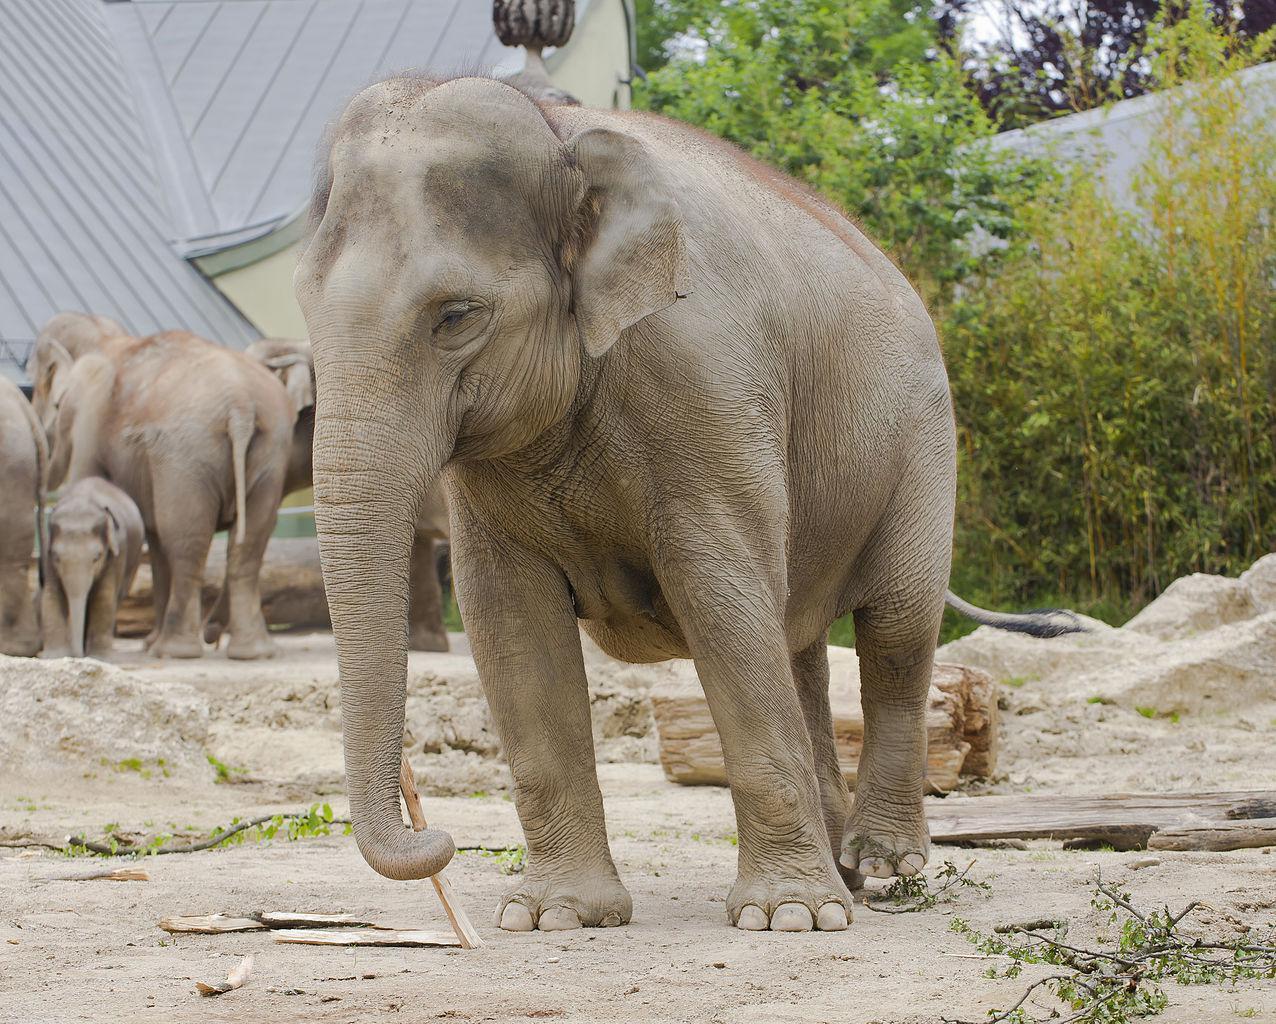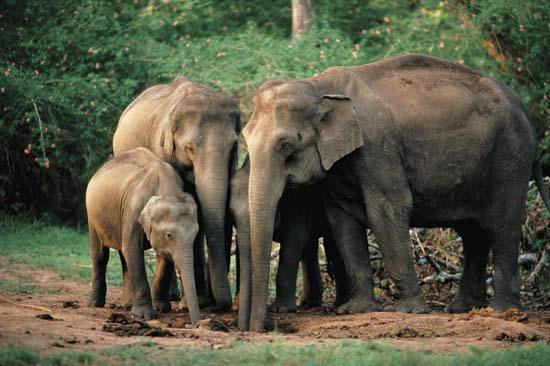The first image is the image on the left, the second image is the image on the right. For the images shown, is this caption "There are two elephanfs in the image pair." true? Answer yes or no. No. The first image is the image on the left, the second image is the image on the right. For the images displayed, is the sentence "The right image contains exactly one elephant." factually correct? Answer yes or no. No. 